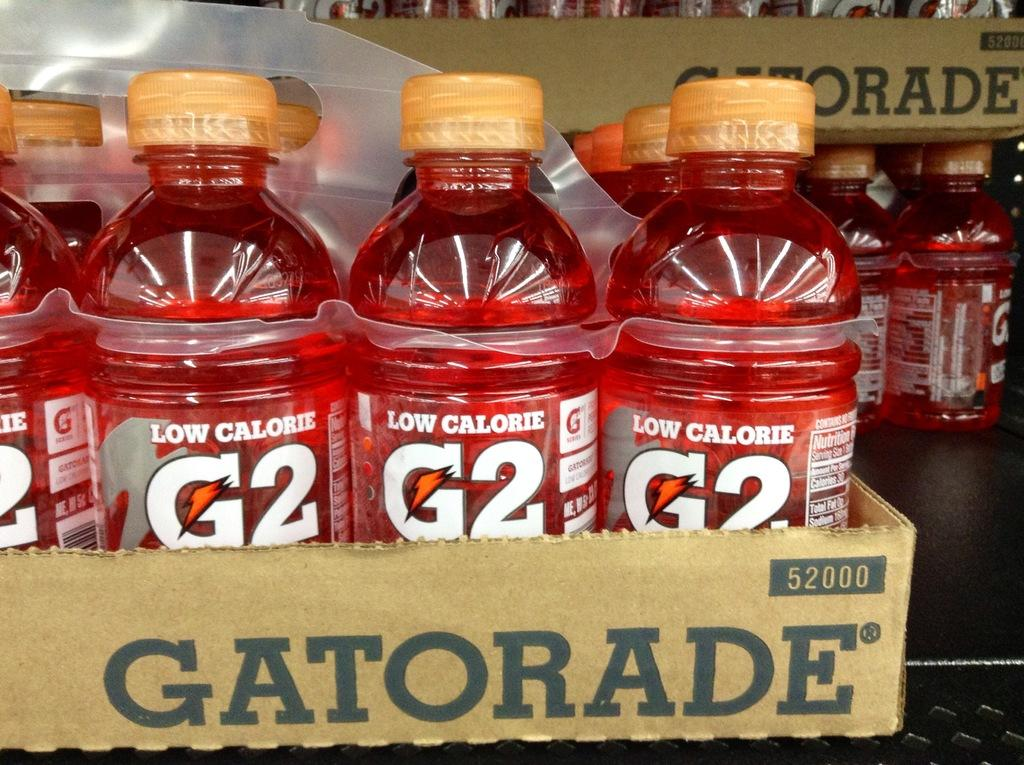What type of product is visible in the image? There are packaged drinking bottles in the image. Can you identify the brand of the product? Yes, the word "GATORADE" is written on one of the packs in the foreground. What type of van is visible in the image? There is no van present in the image; it only features packaged drinking bottles. What scale is used to measure the size of the bottles in the image? The image does not show any scale for measuring the size of the bottles. 